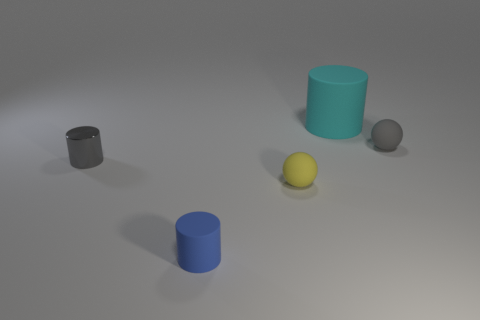Subtract all rubber cylinders. How many cylinders are left? 1 Subtract all gray balls. How many balls are left? 1 Subtract all balls. How many objects are left? 3 Subtract all tiny blue things. Subtract all matte objects. How many objects are left? 0 Add 5 tiny blue rubber cylinders. How many tiny blue rubber cylinders are left? 6 Add 1 matte things. How many matte things exist? 5 Add 2 gray shiny cylinders. How many objects exist? 7 Subtract 0 purple balls. How many objects are left? 5 Subtract 1 cylinders. How many cylinders are left? 2 Subtract all purple balls. Subtract all blue cubes. How many balls are left? 2 